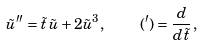<formula> <loc_0><loc_0><loc_500><loc_500>\tilde { u } ^ { \prime \prime } = \tilde { t } \, \tilde { u } + 2 \tilde { u } ^ { 3 } , \quad ( ^ { \prime } ) = \frac { d } { d \tilde { t } } \, ,</formula> 